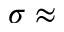<formula> <loc_0><loc_0><loc_500><loc_500>\sigma \approx</formula> 